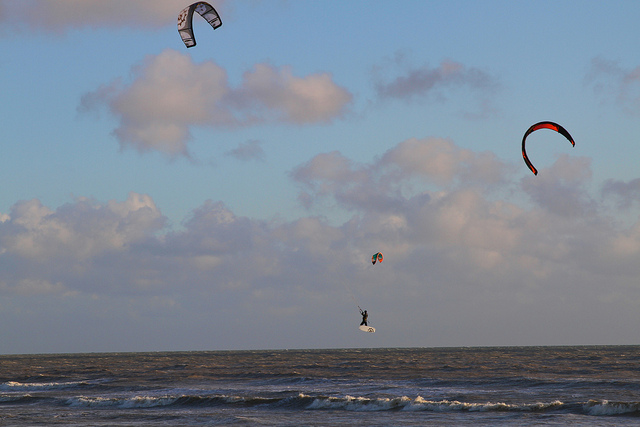What is the background of the image? The background offers a theatrical stage set by nature itself, with the vast and mighty sea meeting the horizon, while the sky above muses with scattered tufts of clouds, suggesting a story that extends far beyond the frame. 